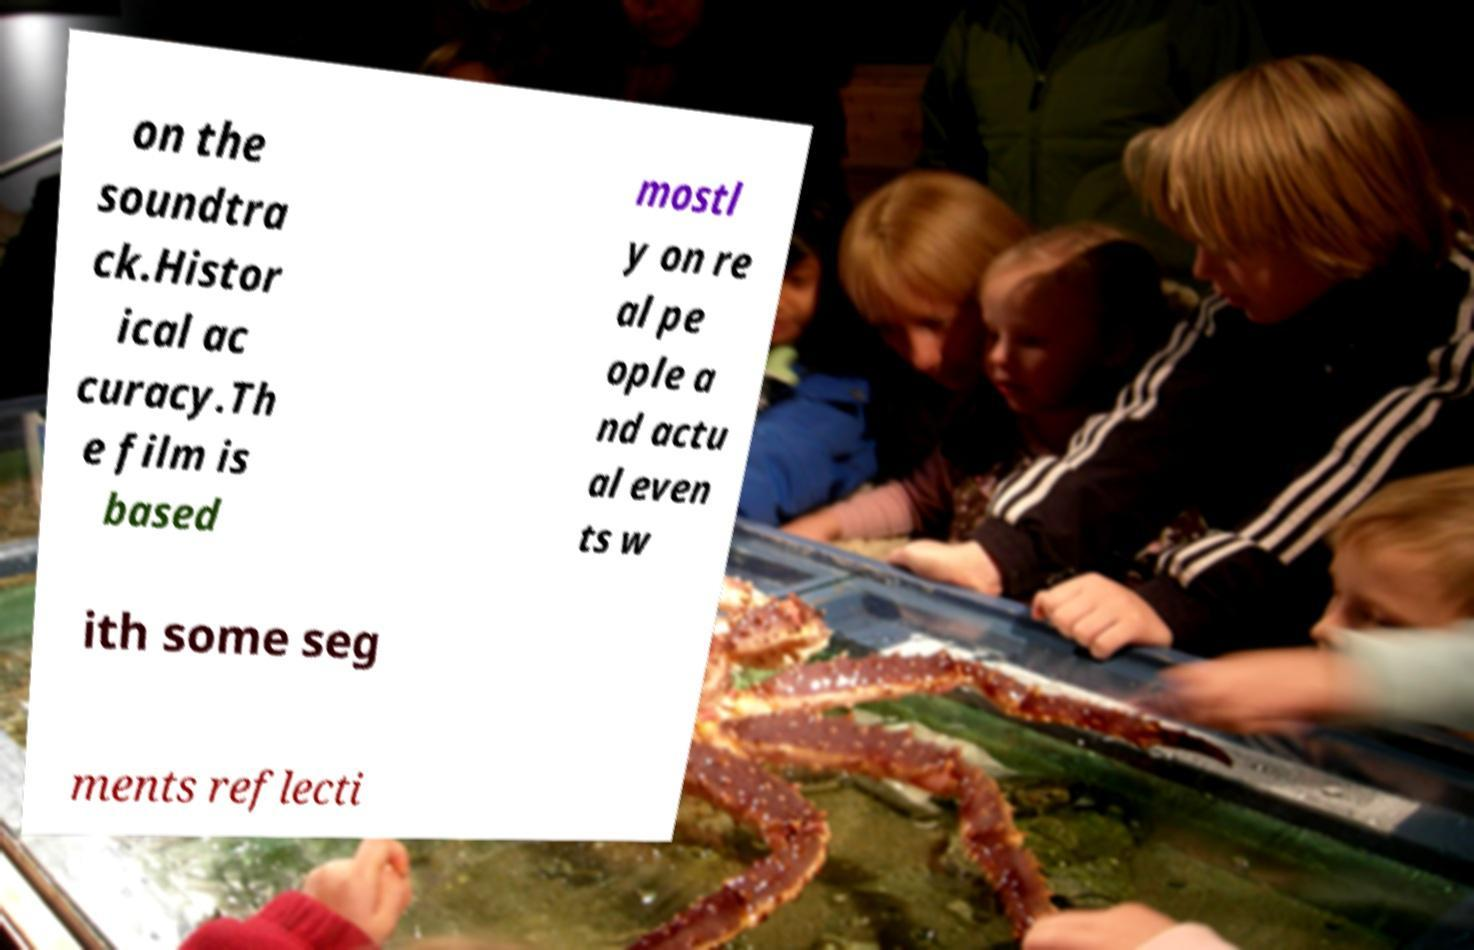Please identify and transcribe the text found in this image. on the soundtra ck.Histor ical ac curacy.Th e film is based mostl y on re al pe ople a nd actu al even ts w ith some seg ments reflecti 